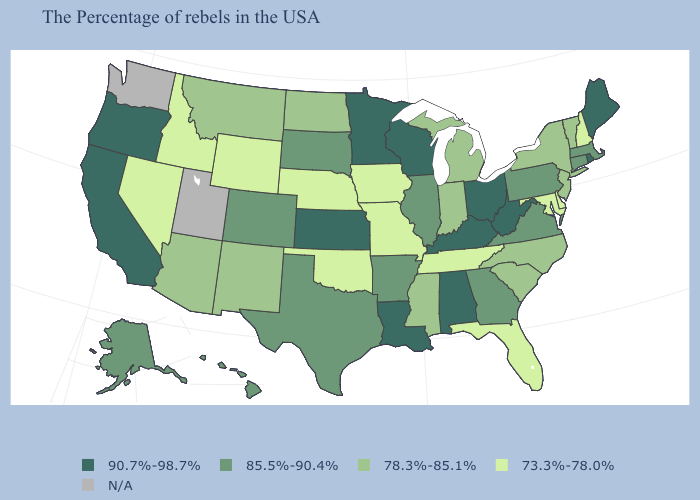Does Wyoming have the lowest value in the USA?
Concise answer only. Yes. What is the lowest value in the MidWest?
Give a very brief answer. 73.3%-78.0%. Name the states that have a value in the range 78.3%-85.1%?
Give a very brief answer. Vermont, New York, New Jersey, North Carolina, South Carolina, Michigan, Indiana, Mississippi, North Dakota, New Mexico, Montana, Arizona. Name the states that have a value in the range N/A?
Write a very short answer. Utah, Washington. Does Rhode Island have the highest value in the Northeast?
Write a very short answer. Yes. Name the states that have a value in the range 78.3%-85.1%?
Give a very brief answer. Vermont, New York, New Jersey, North Carolina, South Carolina, Michigan, Indiana, Mississippi, North Dakota, New Mexico, Montana, Arizona. Does New York have the lowest value in the USA?
Answer briefly. No. What is the value of Indiana?
Keep it brief. 78.3%-85.1%. What is the value of Louisiana?
Quick response, please. 90.7%-98.7%. Name the states that have a value in the range 90.7%-98.7%?
Give a very brief answer. Maine, Rhode Island, West Virginia, Ohio, Kentucky, Alabama, Wisconsin, Louisiana, Minnesota, Kansas, California, Oregon. What is the lowest value in the USA?
Keep it brief. 73.3%-78.0%. Name the states that have a value in the range 78.3%-85.1%?
Write a very short answer. Vermont, New York, New Jersey, North Carolina, South Carolina, Michigan, Indiana, Mississippi, North Dakota, New Mexico, Montana, Arizona. 